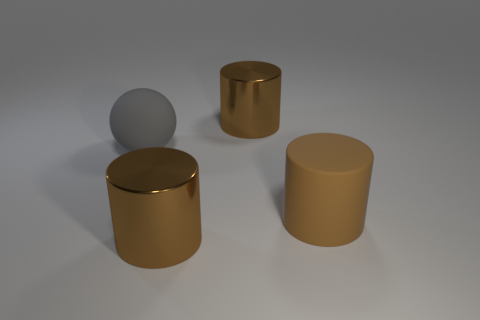Subtract all large brown metallic cylinders. How many cylinders are left? 1 Add 4 shiny spheres. How many objects exist? 8 Subtract all spheres. How many objects are left? 3 Subtract all blue cylinders. Subtract all purple spheres. How many cylinders are left? 3 Subtract all purple cubes. How many red cylinders are left? 0 Subtract all blue rubber cubes. Subtract all big cylinders. How many objects are left? 1 Add 3 big gray spheres. How many big gray spheres are left? 4 Add 4 blue rubber balls. How many blue rubber balls exist? 4 Subtract 0 yellow cylinders. How many objects are left? 4 